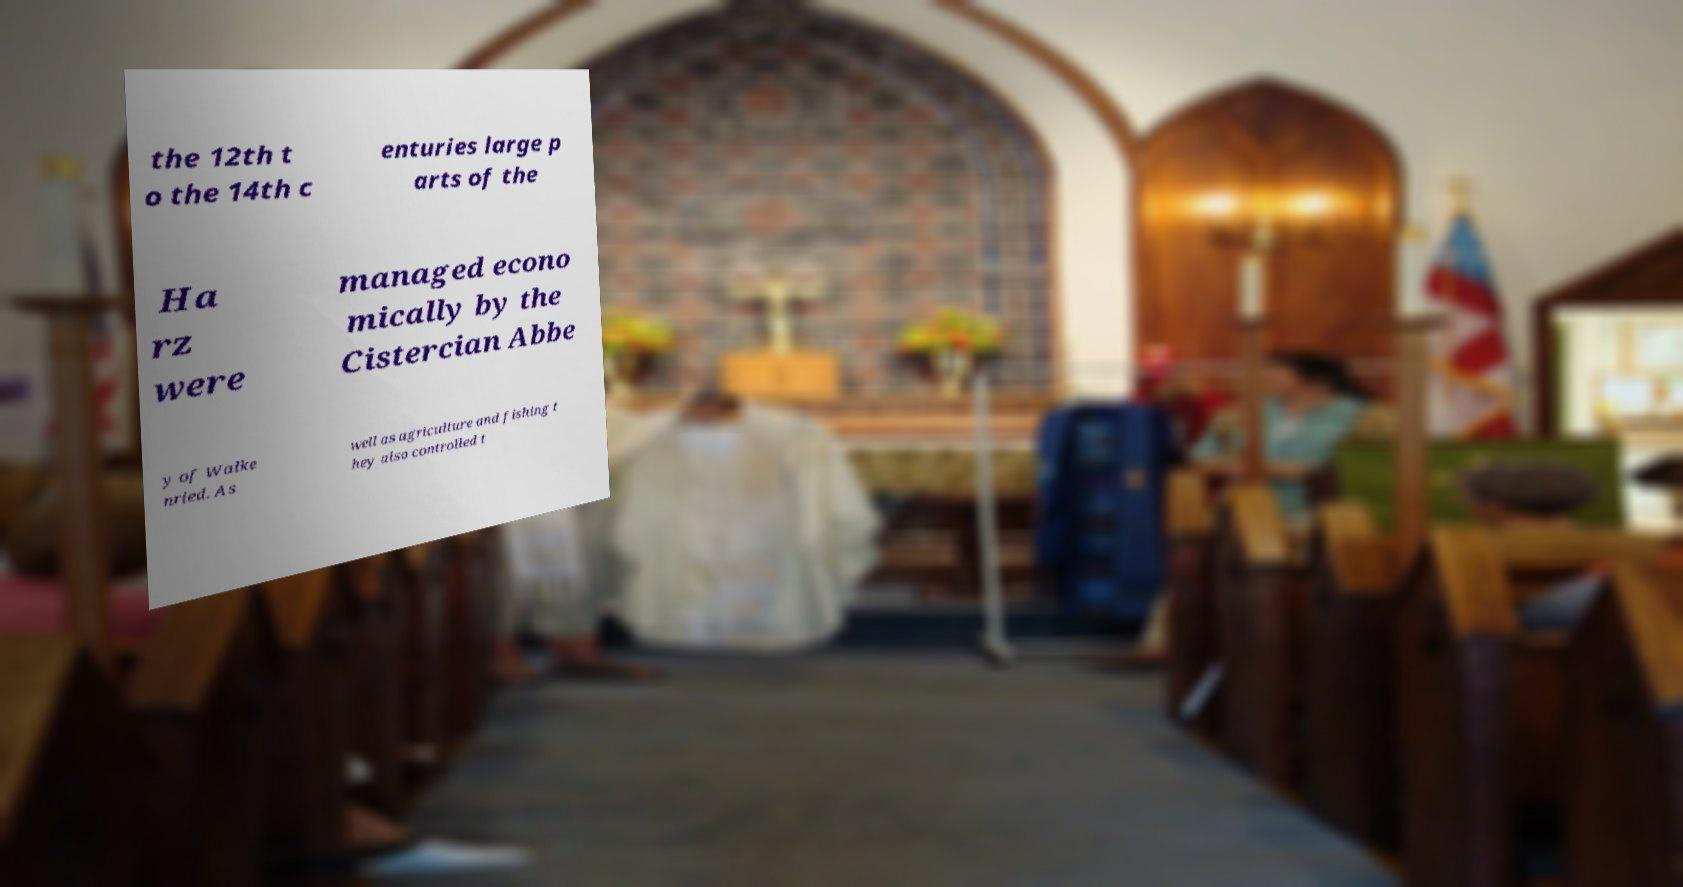I need the written content from this picture converted into text. Can you do that? the 12th t o the 14th c enturies large p arts of the Ha rz were managed econo mically by the Cistercian Abbe y of Walke nried. As well as agriculture and fishing t hey also controlled t 